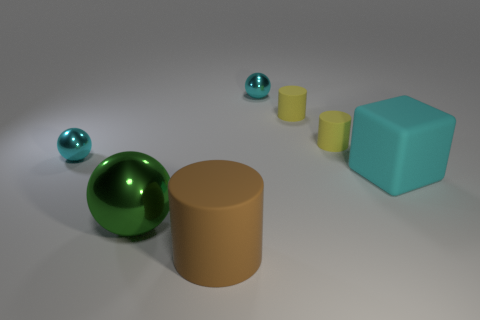The tiny shiny object that is to the right of the shiny sphere that is in front of the cyan shiny object on the left side of the green sphere is what shape?
Provide a short and direct response. Sphere. Is the number of tiny yellow objects that are in front of the brown rubber cylinder the same as the number of big things that are behind the big shiny object?
Keep it short and to the point. No. There is a metallic thing that is the same size as the brown rubber cylinder; what is its color?
Your response must be concise. Green. How many tiny objects are either cyan blocks or yellow matte cylinders?
Provide a short and direct response. 2. What is the thing that is on the right side of the large ball and in front of the block made of?
Ensure brevity in your answer.  Rubber. Is the shape of the object in front of the green thing the same as the metallic object that is right of the big green metallic ball?
Offer a terse response. No. How many things are large objects that are right of the large rubber cylinder or tiny cylinders?
Keep it short and to the point. 3. Does the cyan rubber block have the same size as the green shiny thing?
Provide a succinct answer. Yes. What is the color of the big thing left of the large brown matte cylinder?
Offer a very short reply. Green. There is a block that is the same material as the brown object; what is its size?
Offer a terse response. Large. 